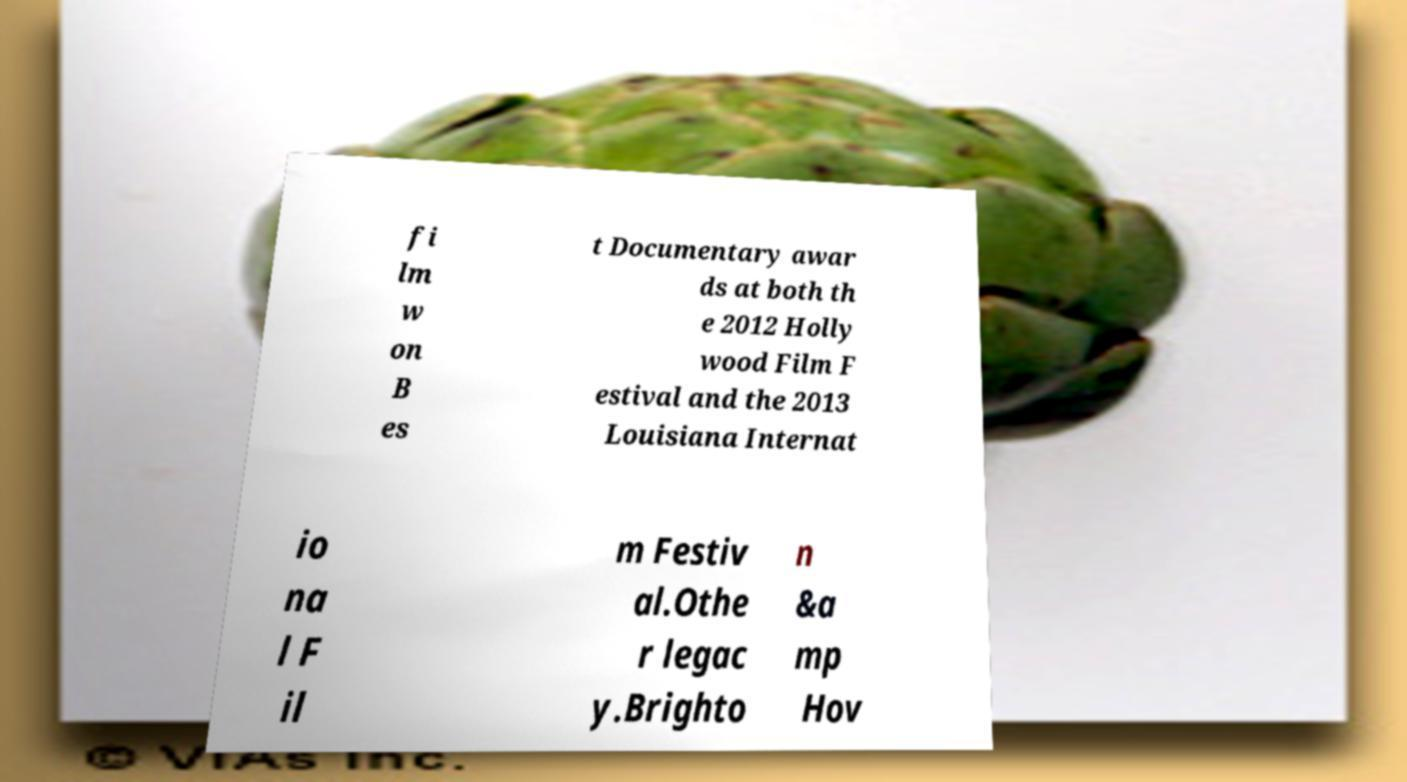For documentation purposes, I need the text within this image transcribed. Could you provide that? fi lm w on B es t Documentary awar ds at both th e 2012 Holly wood Film F estival and the 2013 Louisiana Internat io na l F il m Festiv al.Othe r legac y.Brighto n &a mp Hov 